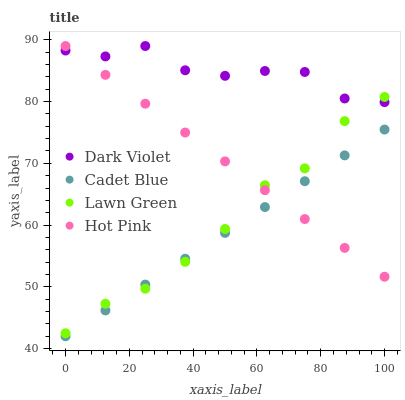Does Cadet Blue have the minimum area under the curve?
Answer yes or no. Yes. Does Dark Violet have the maximum area under the curve?
Answer yes or no. Yes. Does Dark Violet have the minimum area under the curve?
Answer yes or no. No. Does Cadet Blue have the maximum area under the curve?
Answer yes or no. No. Is Cadet Blue the smoothest?
Answer yes or no. Yes. Is Dark Violet the roughest?
Answer yes or no. Yes. Is Dark Violet the smoothest?
Answer yes or no. No. Is Cadet Blue the roughest?
Answer yes or no. No. Does Cadet Blue have the lowest value?
Answer yes or no. Yes. Does Dark Violet have the lowest value?
Answer yes or no. No. Does Hot Pink have the highest value?
Answer yes or no. Yes. Does Cadet Blue have the highest value?
Answer yes or no. No. Is Cadet Blue less than Dark Violet?
Answer yes or no. Yes. Is Dark Violet greater than Cadet Blue?
Answer yes or no. Yes. Does Lawn Green intersect Hot Pink?
Answer yes or no. Yes. Is Lawn Green less than Hot Pink?
Answer yes or no. No. Is Lawn Green greater than Hot Pink?
Answer yes or no. No. Does Cadet Blue intersect Dark Violet?
Answer yes or no. No. 